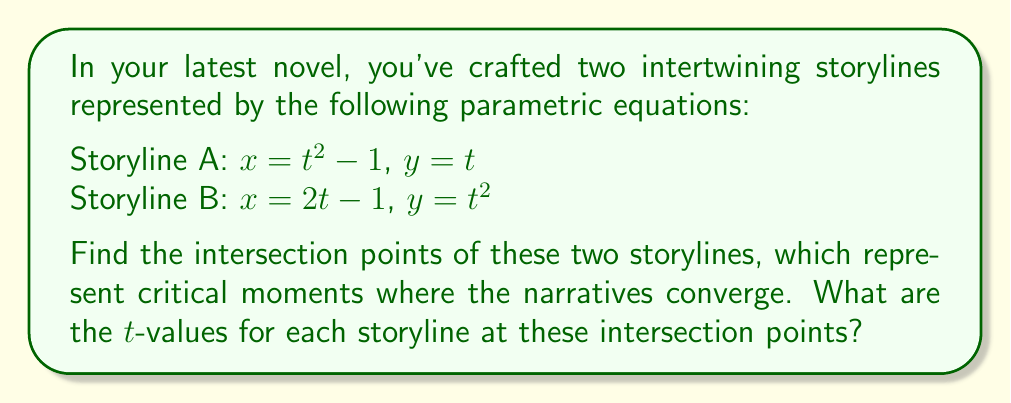Provide a solution to this math problem. To find the intersection points, we need to solve the system of equations:

$$\begin{cases}
t^2 - 1 = 2s - 1 \\
t = s^2
\end{cases}$$

Where $t$ is the parameter for Storyline A and $s$ is the parameter for Storyline B.

1) From the second equation, substitute $t = s^2$ into the first equation:

   $(s^2)^2 - 1 = 2s - 1$

2) Simplify:

   $s^4 - 1 = 2s - 1$
   $s^4 = 2s$

3) Rearrange:

   $s^4 - 2s = 0$
   $s(s^3 - 2) = 0$

4) Solve:

   $s = 0$ or $s^3 = 2$
   $s = 0$ or $s = \sqrt[3]{2}$

5) For Storyline B, we have $s = 0$ and $s = \sqrt[3]{2}$

6) For Storyline A, we need to find the corresponding $t$ values:
   When $s = 0$, $t = s^2 = 0$
   When $s = \sqrt[3]{2}$, $t = s^2 = (\sqrt[3]{2})^2 = \sqrt[3]{4}$

7) Calculate the $(x,y)$ coordinates:

   For $s = 0$ and $t = 0$:
   $x = t^2 - 1 = 0^2 - 1 = -1$
   $y = t = 0$

   For $s = \sqrt[3]{2}$ and $t = \sqrt[3]{4}$:
   $x = t^2 - 1 = (\sqrt[3]{4})^2 - 1 = \sqrt[3]{16} - 1 = 1$
   $y = t = \sqrt[3]{4}$
Answer: The storylines intersect at two points:

1) $(-1, 0)$ when $t_A = 0$ and $t_B = 0$
2) $(1, \sqrt[3]{4})$ when $t_A = \sqrt[3]{4}$ and $t_B = \sqrt[3]{2}$

Where $t_A$ and $t_B$ are the t-values for Storyline A and Storyline B, respectively. 